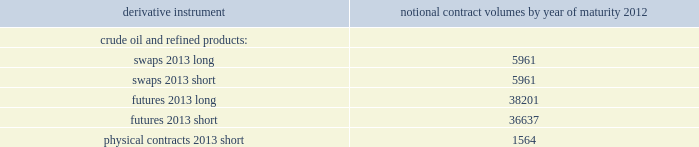Table of contents valero energy corporation and subsidiaries notes to consolidated financial statements ( continued ) cash flow hedges cash flow hedges are used to hedge price volatility in certain forecasted feedstock and refined product purchases , refined product sales , and natural gas purchases .
The objective of our cash flow hedges is to lock in the price of forecasted feedstock , product or natural gas purchases or refined product sales at existing market prices that we deem favorable .
As of december 31 , 2011 , we had the following outstanding commodity derivative instruments that were entered into to hedge forecasted purchases or sales of crude oil and refined products .
The information presents the notional volume of outstanding contracts by type of instrument and year of maturity ( volumes in thousands of barrels ) .
Notional contract volumes by year of maturity derivative instrument 2012 .

How many more long future notional contracts mature by 2012 than short futures? 
Computations: (38201 - 36637)
Answer: 1564.0. 